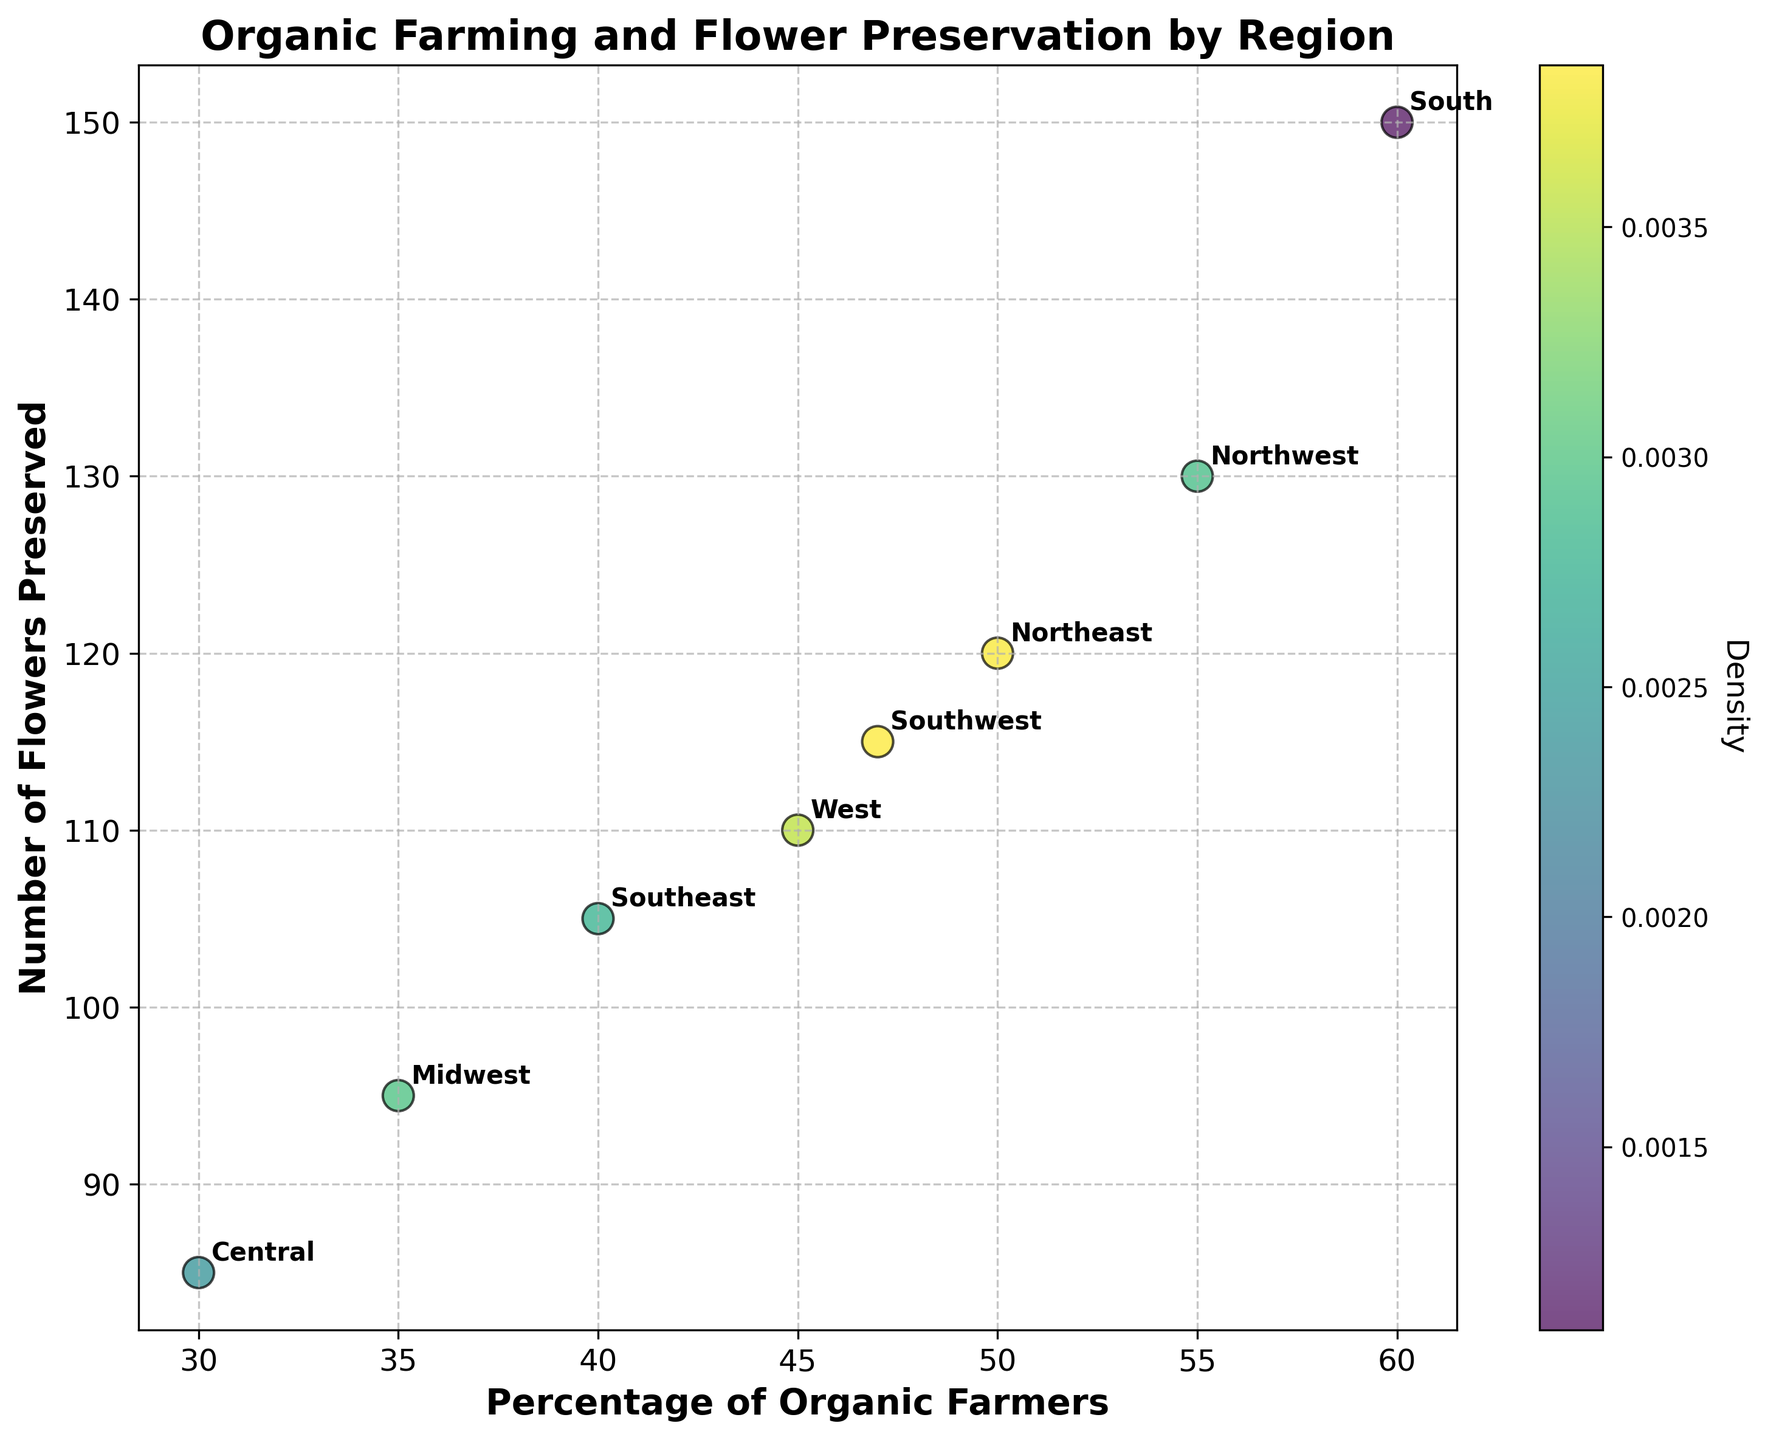What is the title of the figure? The title is located at the top of the figure and provides a summary of what the figure represents. In this case, it is clearly written above the plot.
Answer: Organic Farming and Flower Preservation by Region What does the x-axis represent? The x-axis label is located below the horizontal axis of the plot. It shows what is measured on this axis.
Answer: Percentage of Organic Farmers How many regions are represented in the plot? Each region is labeled on the plot as an annotation next to the respective data points. By counting these unique labels, we can determine the number of regions.
Answer: 8 Which region has the highest number of flowers preserved? Look for the data point on the y-axis (vertical axis) with the highest value and note the region labeled next to it.
Answer: South Which region has the lowest percentage of organic farmers? Identify the data point with the smallest value on the x-axis and note the corresponding region label next to it.
Answer: Central What's the average percentage of organic farmers across all regions? Sum all the percentages and divide by the number of regions: (50 + 35 + 60 + 45 + 55 + 40 + 47 + 30) / 8 = 45.25
Answer: 45.25 Who preserves more flowers, the West or the Midwest? Compare the vertical positions (y-axis values) of the labeled points for the West and Midwest regions.
Answer: West Is there a positive correlation between the percentage of organic farmers and the number of flowers preserved? A positive correlation would be indicated if data points trend upward from left to right. Observing the general direction of the data points helps answer this.
Answer: Yes Which region has the median percentage of organic farmers? Sort the regions by their percentage of organic farmers and find the middle value of the sorted list. Here: [30, 35, 40, 45, 47, 50, 55, 60]. The median is between the 4th and 5th values: (45 + 47) / 2 = 46
Answer: Southwest What is the density color of the region with 50% organic farmers? Locate the data point for 50% on the x-axis, observe its color on the plot and refer to the color bar to understand the density value it represents.
Answer: Medium density 